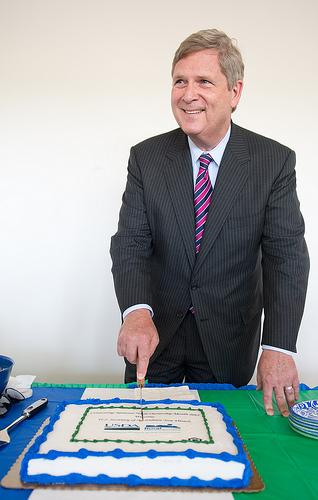Identify an object the man is holding in his hand. The man is holding a knife in his hand. Briefly describe the table setting in the image. There are stacked plates, eyeglasses, a spatula, and a blue and green tablecloth on the table. Describe the environment in which the man is located in the image. The man is in a room, possibly a house, celebrating by cutting a cake. Mention the attire of the man in the image and any specific accessories he is wearing. The man is wearing a suit, a striped tie, and a ring on his left hand. What is the central activity of the man in the image? The man is preparing to cut a rectangular blue, white, and green cake. List three items found on the table in the image. Eyeglasses, stacked plates, and a spatula can be found on the table. Describe the appearance and location of the necktie in the image. The tie around the man's neck is striped and measures 19 by 19 pixels. Elaborate on the specific details of the cake in the image. The cake is rectangular, uncut, and uneaten, with blue, white, and green trim. Provide a brief overview of the entire scene captured in the image. A man in a nice suit and striped tie is happily cutting a rectangular cake in a celebratory setting, with plates, eyeglasses, and a spatula on a table covered with a blue and green tablecloth. Mention the overall theme of the scene in the image. The scene represents a man in a room having a celebration by cutting a cake. 